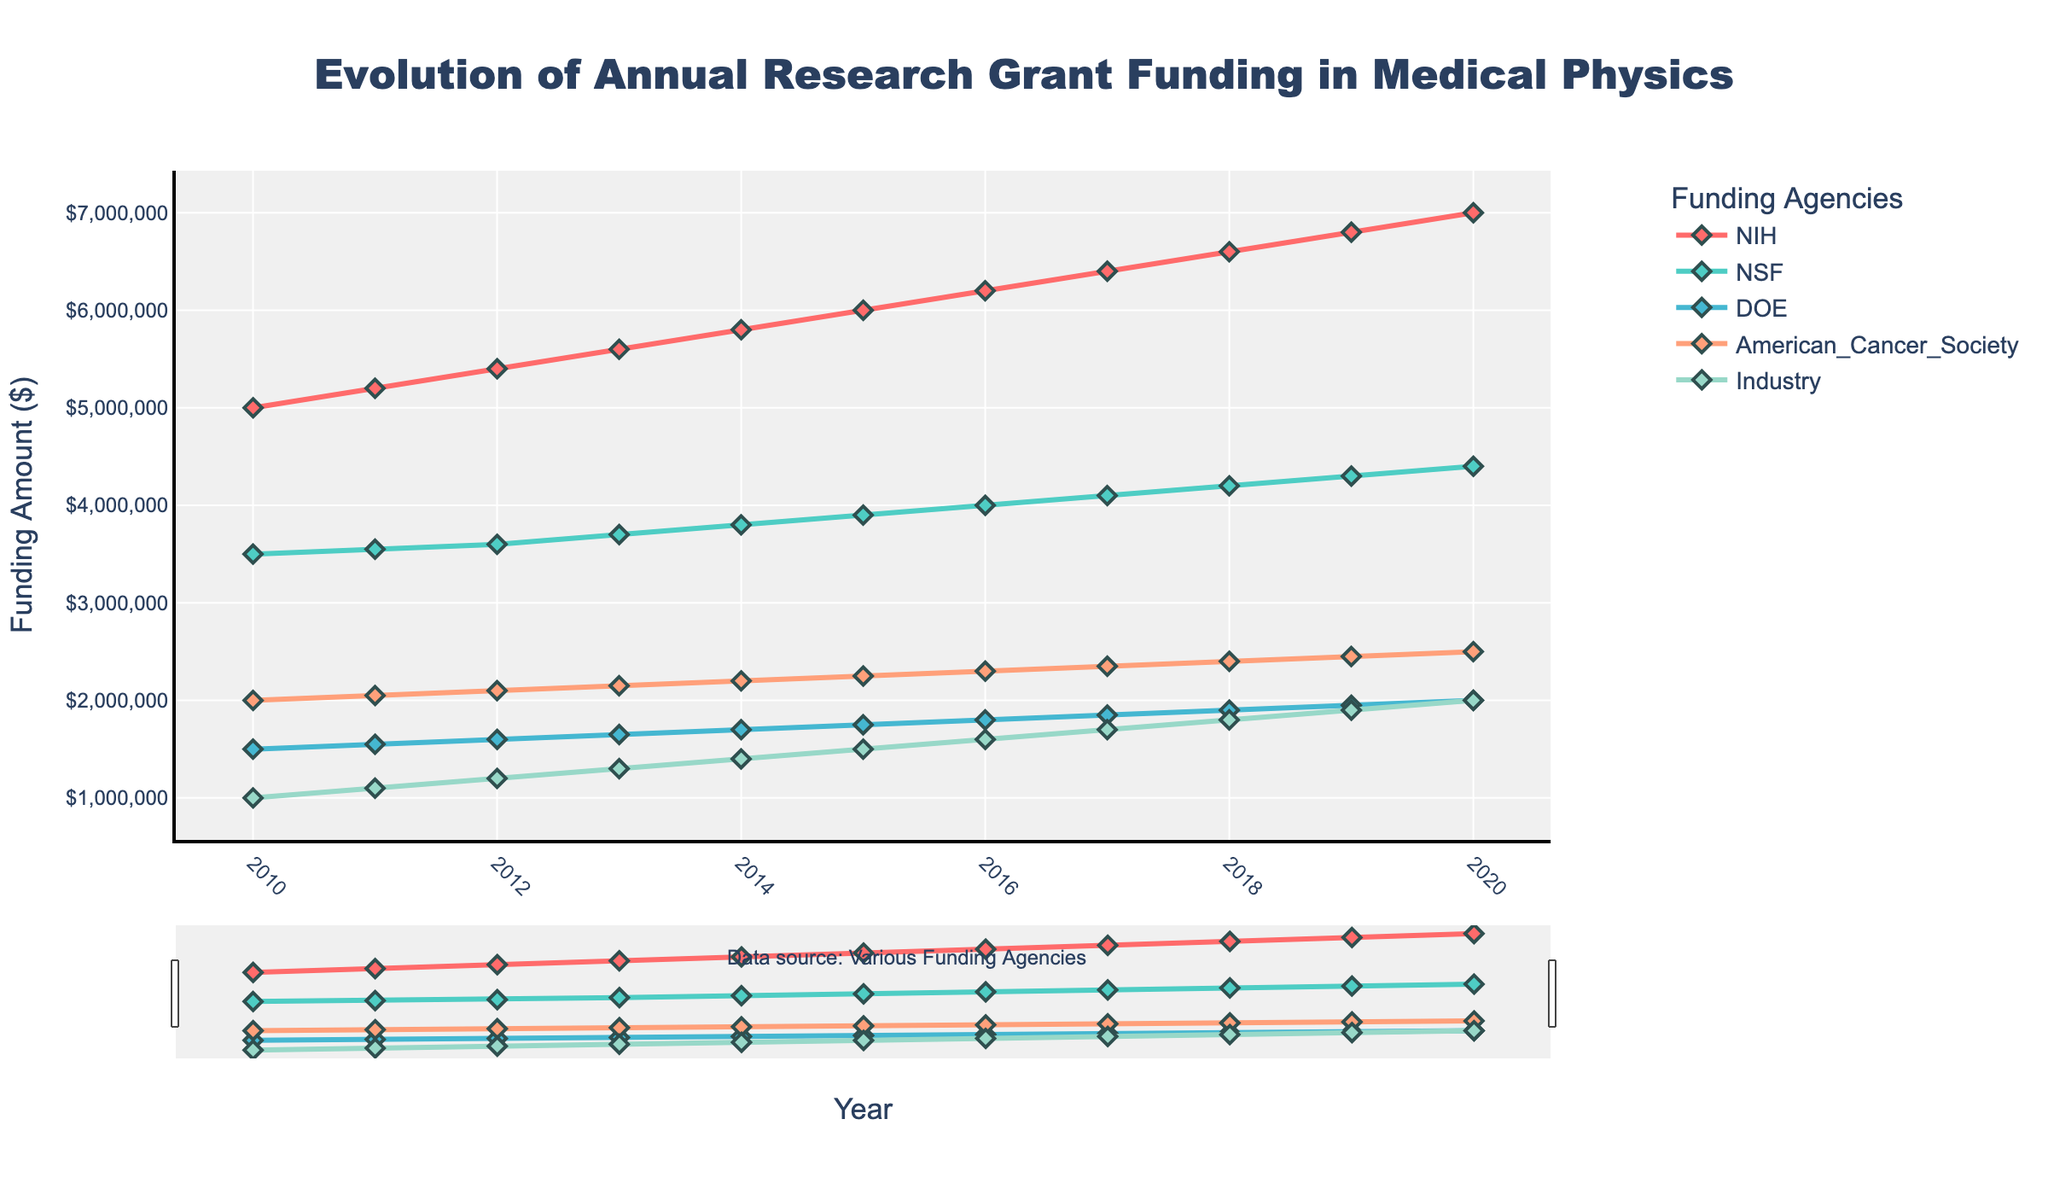What's the title of the plot? The title is usually displayed at the top of the plot. It helps to identify the main subject or theme of the visualized data. In this case, the title reads "Evolution of Annual Research Grant Funding in Medical Physics."
Answer: "Evolution of Annual Research Grant Funding in Medical Physics" What is the funding amount for NSF in 2015? Locate the year 2015 on the x-axis and follow the NSF line (usually identified by color or label). The corresponding y-value shows the funding amount for that year.
Answer: \$3,900,000 Which funding agency has the highest funding in 2020? Look at the funding amounts for each agency in the year 2020. Compare the values and identify the highest one. The NIH has the highest funding amount shown by the highest y-value in 2020.
Answer: NIH How much did the NIH funding amount increase from 2010 to 2020? Subtract the 2010 NIH funding amount from the 2020 NIH funding amount. 2020 amount is \$7,000,000, and 2010 amount is \$5,000,000. The increase is \$7,000,000 - \$5,000,000.
Answer: \$2,000,000 Which funding agency has the most consistent increase in funding over the years? Observe the trends of each funding agency. "Consistent increase" means a steady and regular rise with minimal fluctuations. The NSF funding trend appears to be most consistent, with a steady linear rise.
Answer: NSF What's the total funding from Industry over the decade? Add the funding amounts from Industry for each year from 2010 to 2020. Sum = \$1,000,000 + \$1,100,000 + \$1,200,000 + \$1,300,000 + \$1,400,000 + \$1,500,000 + \$1,600,000 + \$1,700,000 + \$1,800,000 + \$1,900,000 + \$2,000,000.
Answer: \$17,500,000 In which year did the American Cancer Society reach \$2,250,000 in funding? Identify the year on the x-axis where the y-value for the American Cancer Society line reaches \$2,250,000.
Answer: 2015 Compare the funding trends of DOE and Industry from 2018 to 2020. Which had a faster growth rate? Examine the slopes of the lines for DOE and Industry between 2018 and 2020. Calculating the slope (change in funding amount divided by the change in years) shows Industry increased by \$200,000/year (\[2020 amount = \$2,000,000\] - \[2018 amount = \$1,800,000\]) versus DOE by \$150,000/year (2020 amount = \$2,000,000 - 2018 amount = \$1,900,000).
Answer: Industry What's the average annual funding for American Cancer Society over the period? Sum up the annual funding amounts from 2010 to 2020, then divide by the number of years (11). Sum = \$2,000,000 + \$2,050,000 + \$2,100,000 + \$2,150,000 + \$2,200,000 + \$2,250,000 + \$2,300,000 + \$2,350,000 + \$2,400,000 + \$2,450,000 + \$2,500,000. Average = \$24,700,000/11.
Answer: \$2,245,455 